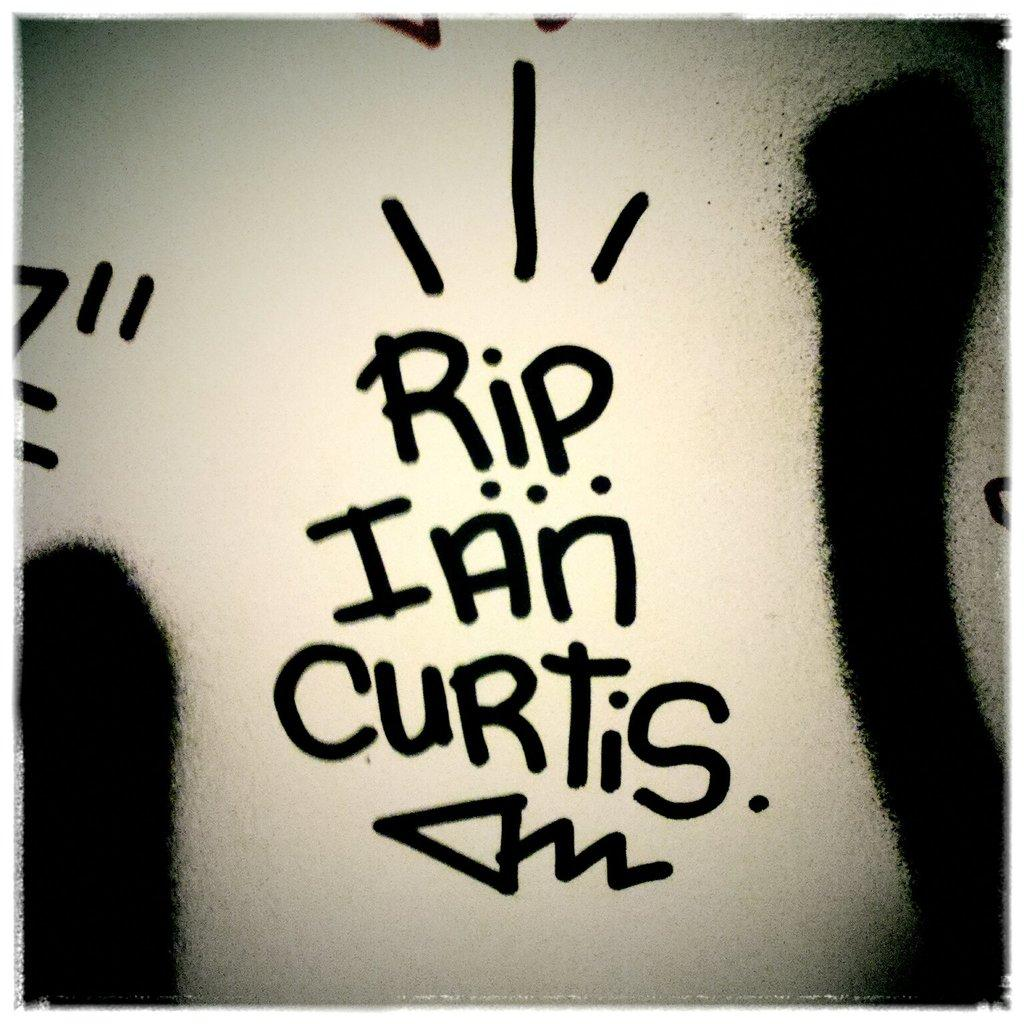<image>
Provide a brief description of the given image. white wall with spray painted words rip ian curtis 